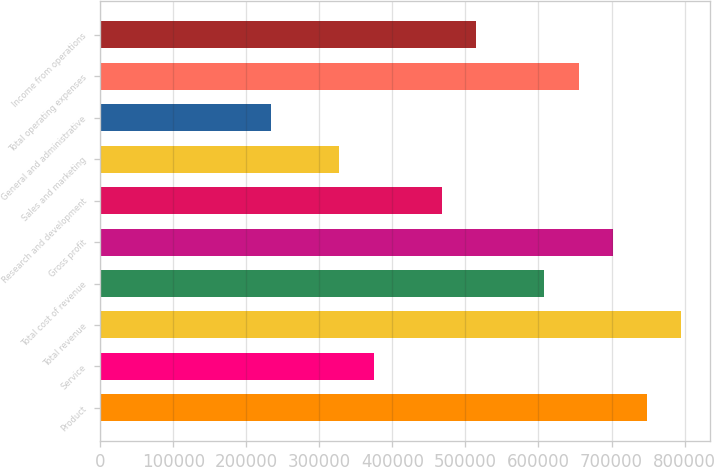Convert chart to OTSL. <chart><loc_0><loc_0><loc_500><loc_500><bar_chart><fcel>Product<fcel>Service<fcel>Total revenue<fcel>Total cost of revenue<fcel>Gross profit<fcel>Research and development<fcel>Sales and marketing<fcel>General and administrative<fcel>Total operating expenses<fcel>Income from operations<nl><fcel>748586<fcel>374294<fcel>795373<fcel>608227<fcel>701800<fcel>467867<fcel>327507<fcel>233934<fcel>655013<fcel>514654<nl></chart> 